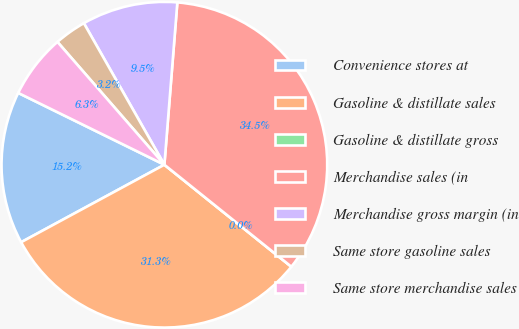<chart> <loc_0><loc_0><loc_500><loc_500><pie_chart><fcel>Convenience stores at<fcel>Gasoline & distillate sales<fcel>Gasoline & distillate gross<fcel>Merchandise sales (in<fcel>Merchandise gross margin (in<fcel>Same store gasoline sales<fcel>Same store merchandise sales<nl><fcel>15.16%<fcel>31.34%<fcel>0.0%<fcel>34.5%<fcel>9.5%<fcel>3.17%<fcel>6.33%<nl></chart> 